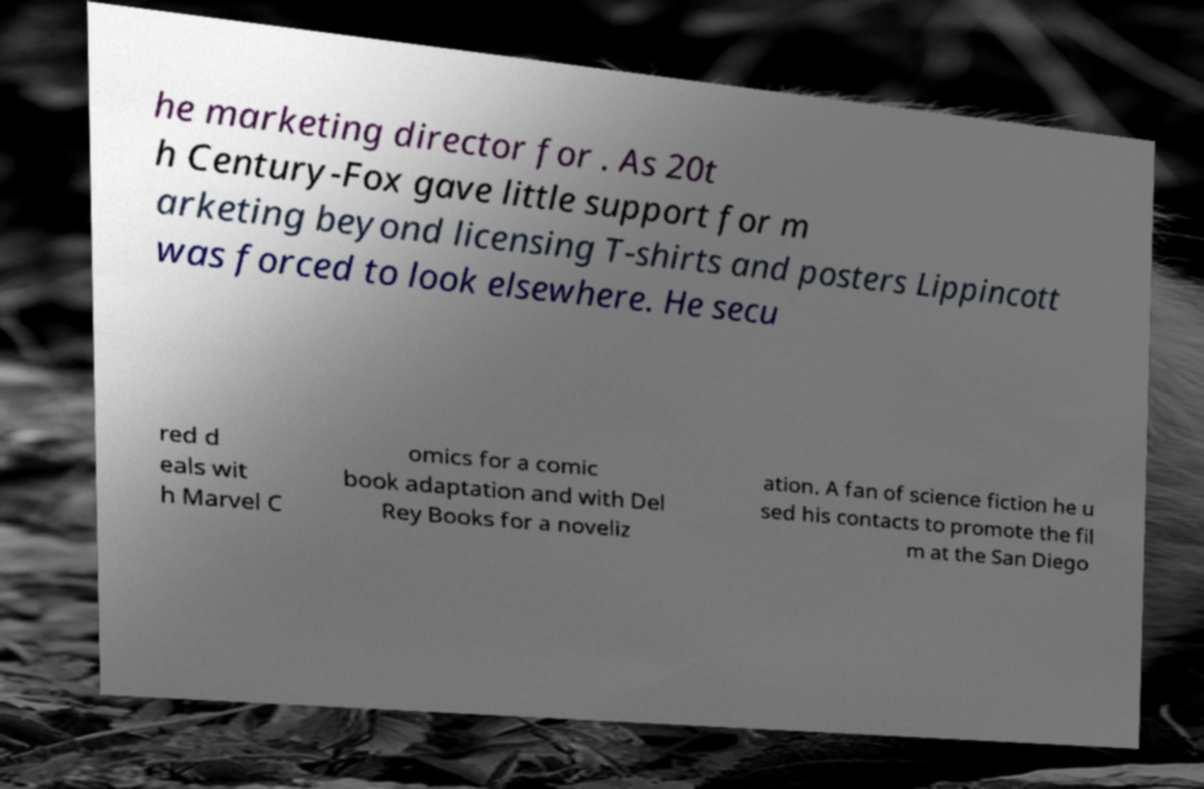Could you assist in decoding the text presented in this image and type it out clearly? he marketing director for . As 20t h Century-Fox gave little support for m arketing beyond licensing T-shirts and posters Lippincott was forced to look elsewhere. He secu red d eals wit h Marvel C omics for a comic book adaptation and with Del Rey Books for a noveliz ation. A fan of science fiction he u sed his contacts to promote the fil m at the San Diego 